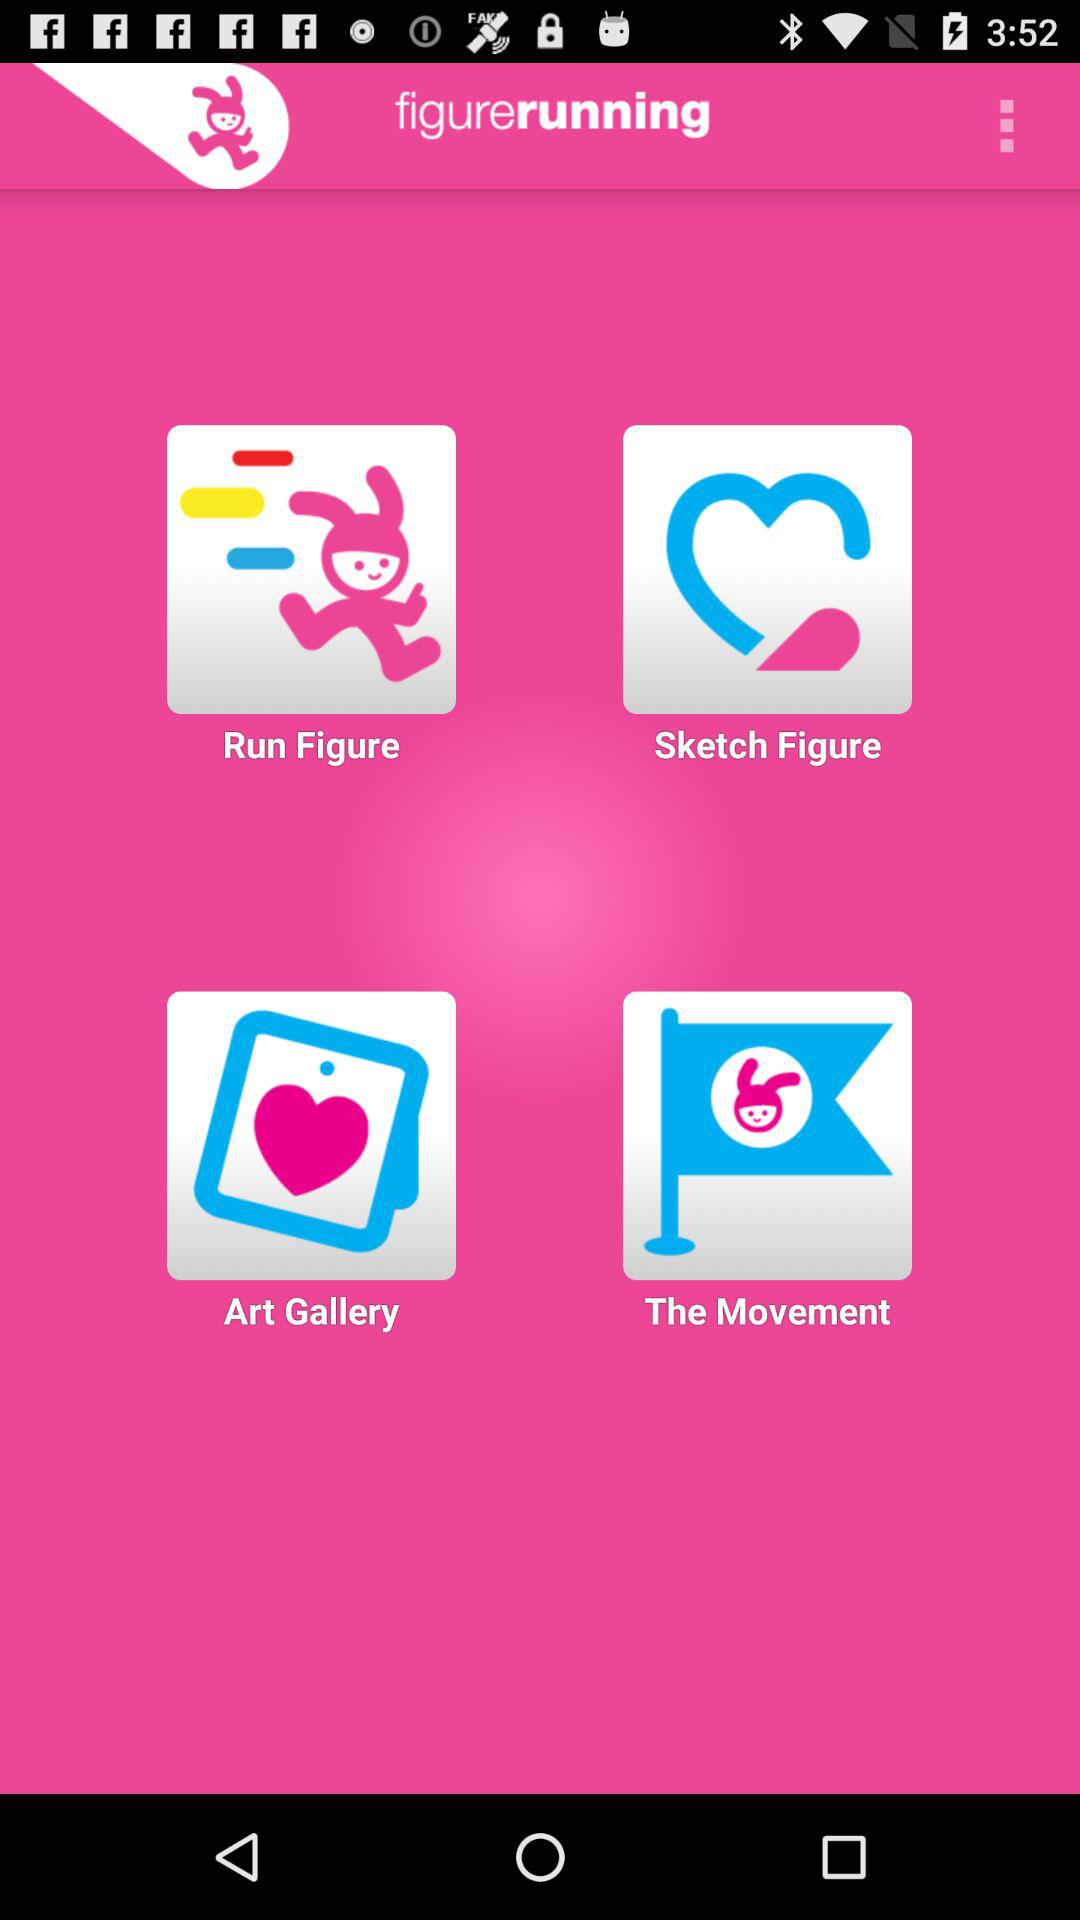What is the application name? The application name is "figurerunning". 